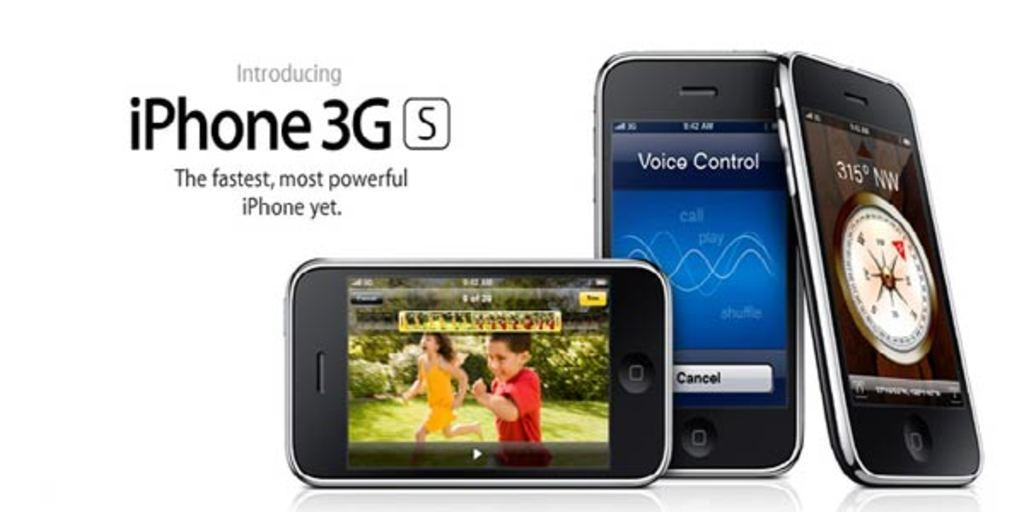<image>
Offer a succinct explanation of the picture presented. an iPhone that is near some other phones 